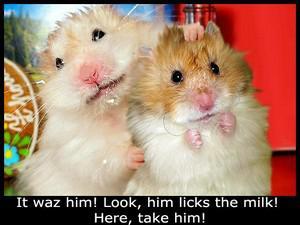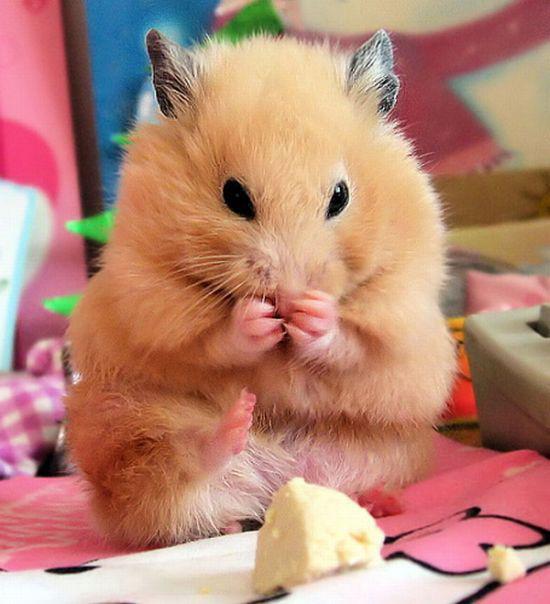The first image is the image on the left, the second image is the image on the right. Examine the images to the left and right. Is the description "An image includes an upright hamster grasping a piece of food nearly as big as its head." accurate? Answer yes or no. No. The first image is the image on the left, the second image is the image on the right. Evaluate the accuracy of this statement regarding the images: "A hamster in the right image is eating something.". Is it true? Answer yes or no. Yes. 